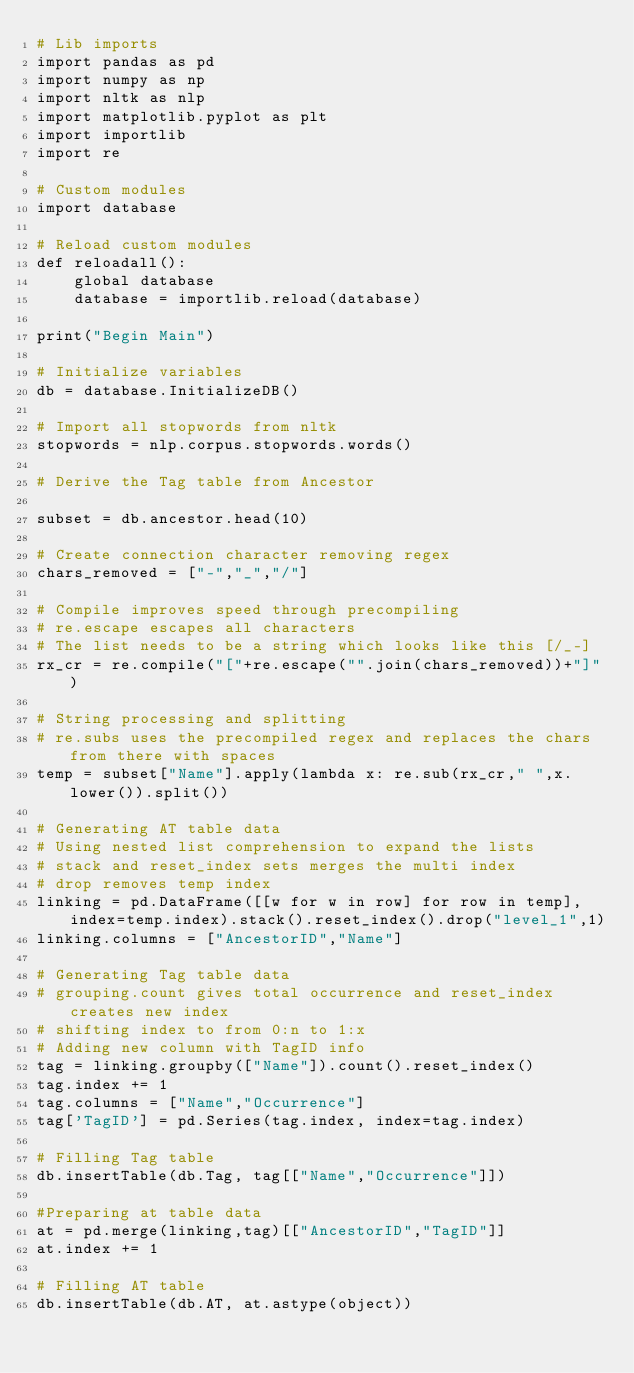<code> <loc_0><loc_0><loc_500><loc_500><_Python_># Lib imports
import pandas as pd
import numpy as np
import nltk as nlp
import matplotlib.pyplot as plt
import importlib
import re

# Custom modules
import database

# Reload custom modules
def reloadall():
    global database
    database = importlib.reload(database)
    
print("Begin Main")

# Initialize variables
db = database.InitializeDB()

# Import all stopwords from nltk
stopwords = nlp.corpus.stopwords.words()

# Derive the Tag table from Ancestor

subset = db.ancestor.head(10)

# Create connection character removing regex
chars_removed = ["-","_","/"]

# Compile improves speed through precompiling
# re.escape escapes all characters 
# The list needs to be a string which looks like this [/_-]
rx_cr = re.compile("["+re.escape("".join(chars_removed))+"]")

# String processing and splitting
# re.subs uses the precompiled regex and replaces the chars from there with spaces
temp = subset["Name"].apply(lambda x: re.sub(rx_cr," ",x.lower()).split())

# Generating AT table data
# Using nested list comprehension to expand the lists
# stack and reset_index sets merges the multi index
# drop removes temp index
linking = pd.DataFrame([[w for w in row] for row in temp], index=temp.index).stack().reset_index().drop("level_1",1)
linking.columns = ["AncestorID","Name"]

# Generating Tag table data
# grouping.count gives total occurrence and reset_index creates new index
# shifting index to from 0:n to 1:x
# Adding new column with TagID info
tag = linking.groupby(["Name"]).count().reset_index()
tag.index += 1
tag.columns = ["Name","Occurrence"]
tag['TagID'] = pd.Series(tag.index, index=tag.index)

# Filling Tag table
db.insertTable(db.Tag, tag[["Name","Occurrence"]])

#Preparing at table data
at = pd.merge(linking,tag)[["AncestorID","TagID"]]
at.index += 1

# Filling AT table
db.insertTable(db.AT, at.astype(object))




</code> 